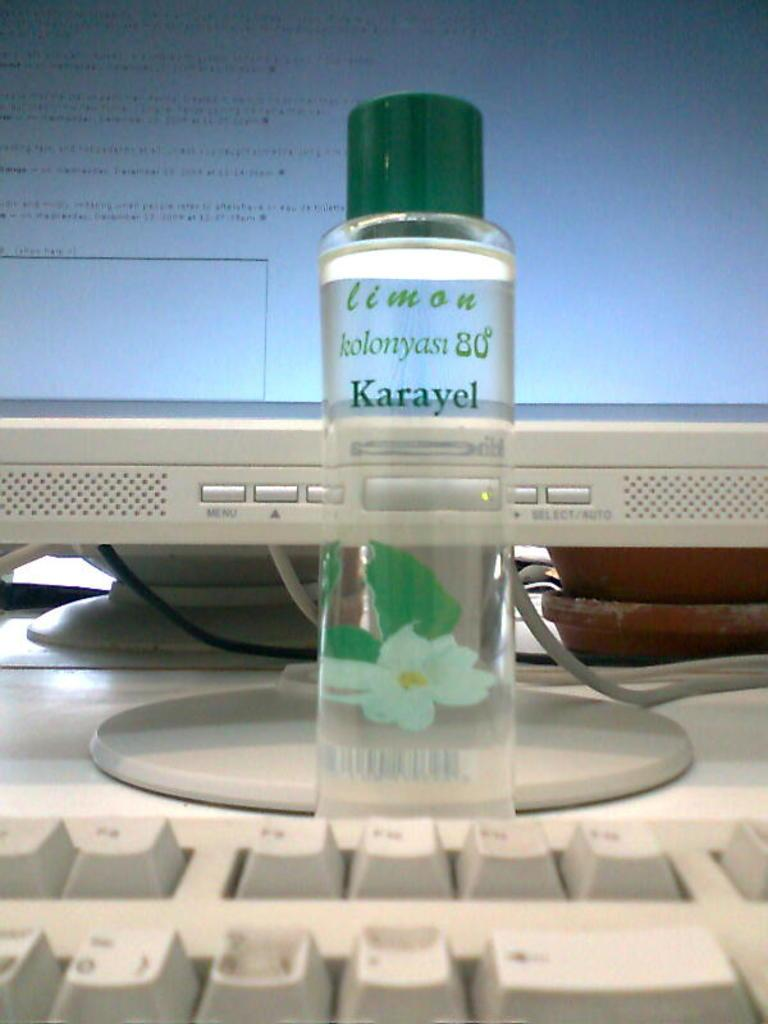What electronic device is visible in the image? There is a monitor in the image. What is placed in front of the monitor? There is a bottle in front of the monitor. What is placed in front of the bottle? There is a keyboard in front of the bottle. What else can be seen in the image besides the monitor, bottle, and keyboard? There are wires visible in the image. What type of credit can be seen being used to paste a town in the image? There is no credit, pasting, or town present in the image. 